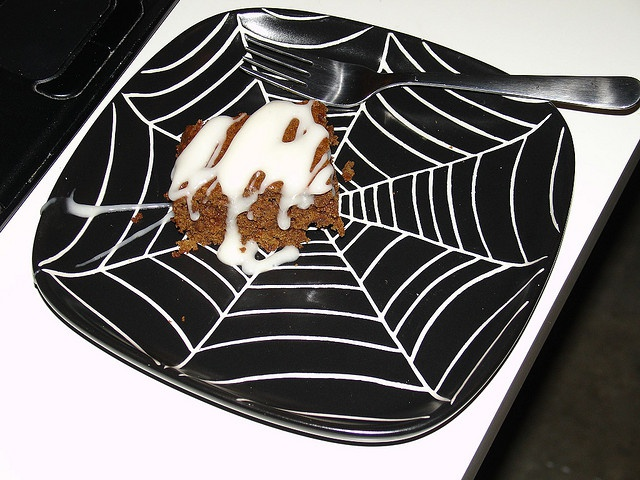Describe the objects in this image and their specific colors. I can see dining table in black and gray tones, cake in black, ivory, maroon, and brown tones, and fork in black, gray, darkgray, and lightgray tones in this image. 